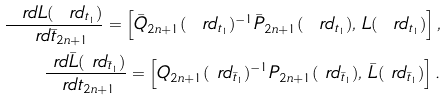Convert formula to latex. <formula><loc_0><loc_0><loc_500><loc_500>\frac { \ r d L ( \ r d _ { t _ { 1 } } ) } { \ r d \bar { t } _ { 2 n + 1 } } = \left [ \bar { Q } _ { 2 n + 1 } ( \ r d _ { t _ { 1 } } ) ^ { - 1 } \bar { P } _ { 2 n + 1 } ( \ r d _ { t _ { 1 } } ) , \, L ( \ r d _ { t _ { 1 } } ) \right ] , \\ \frac { \ r d \bar { L } ( \ r d _ { \bar { t } _ { 1 } } ) } { \ r d t _ { 2 n + 1 } } = \left [ Q _ { 2 n + 1 } ( \ r d _ { \bar { t } _ { 1 } } ) ^ { - 1 } P _ { 2 n + 1 } ( \ r d _ { \bar { t } _ { 1 } } ) , \, \bar { L } ( \ r d _ { \bar { t } _ { 1 } } ) \right ] .</formula> 